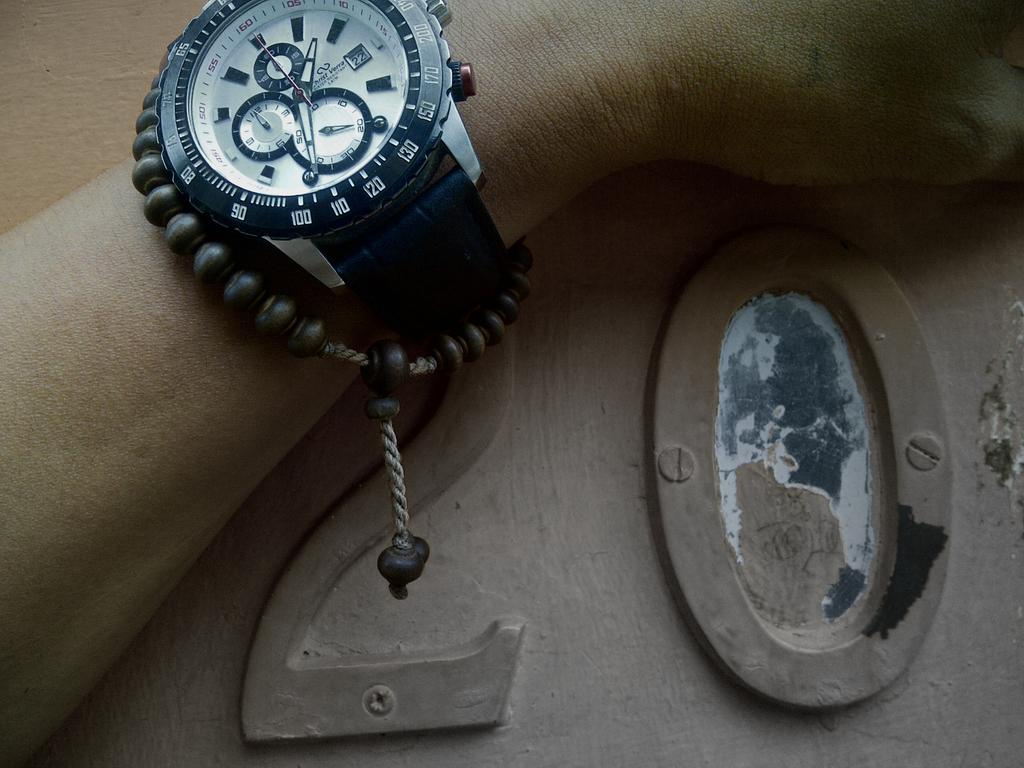What part of the human body is visible in the image? There is a human hand in the image. What accessory is the hand wearing? The hand is wearing a wrist watch. Are there any other accessories visible on the hand? Yes, the hand is also wearing a bracelet. What type of copper cherry can be seen in the cemetery in the image? There is no copper cherry or cemetery present in the image; it only features a human hand wearing a wrist watch and a bracelet. 